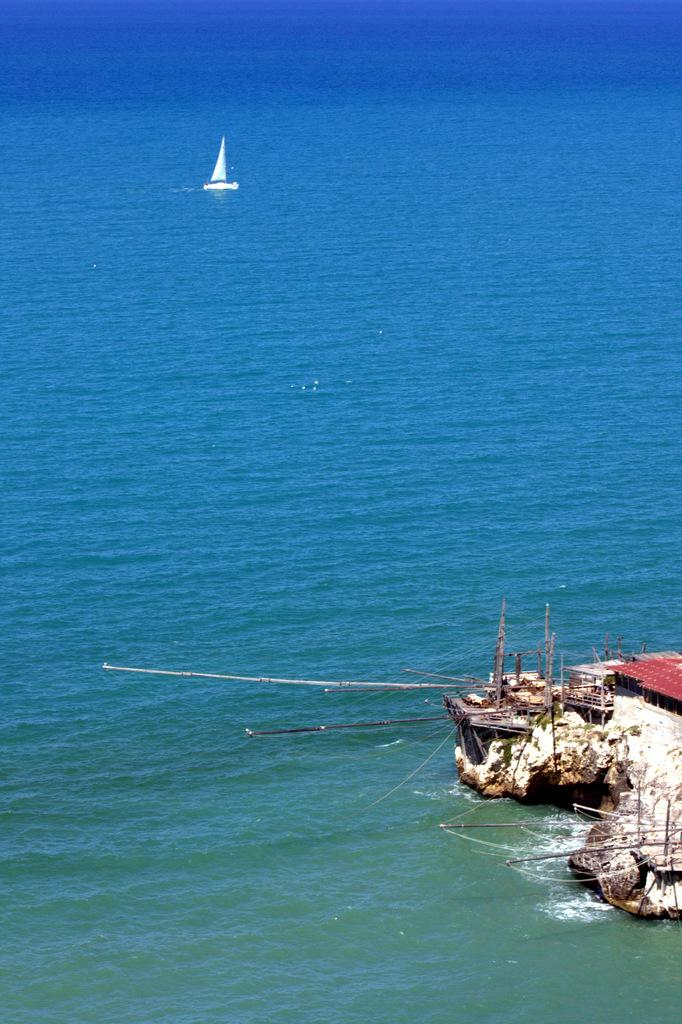What is the main subject of the image? The main subject of the image is a boat. Where is the boat located? The boat is on the water. What else can be seen in the image besides the boat? There is a sea shore visible in the image. How many eggs are visible on the sea shore in the image? There are no eggs visible on the sea shore in the image. What type of ray is swimming near the boat in the image? There is no ray visible near the boat in the image. 